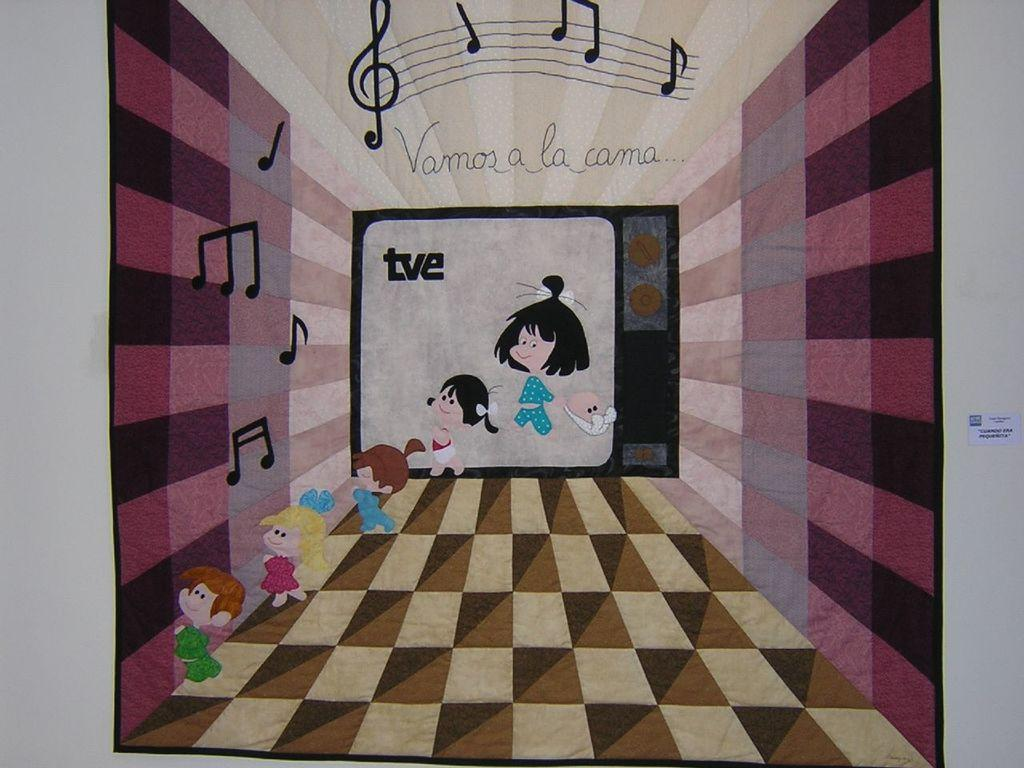Provide a one-sentence caption for the provided image. animated poster with the words vamos a la cama. 